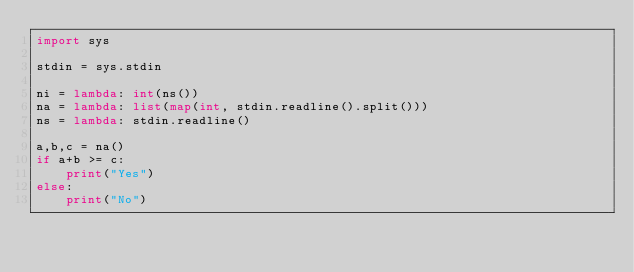Convert code to text. <code><loc_0><loc_0><loc_500><loc_500><_Python_>import sys

stdin = sys.stdin

ni = lambda: int(ns())
na = lambda: list(map(int, stdin.readline().split()))
ns = lambda: stdin.readline()

a,b,c = na()
if a+b >= c:
    print("Yes")
else:
    print("No")
</code> 